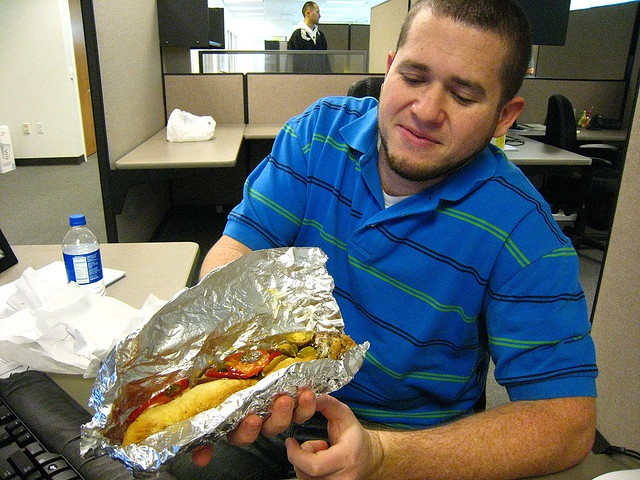Describe the objects in this image and their specific colors. I can see people in tan, blue, black, navy, and brown tones, sandwich in tan, orange, olive, gold, and maroon tones, chair in tan, black, gray, darkgray, and darkgreen tones, keyboard in tan, black, and gray tones, and hot dog in tan, maroon, and olive tones in this image. 